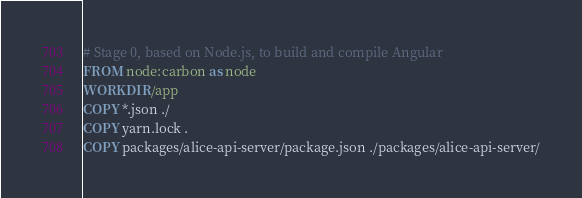Convert code to text. <code><loc_0><loc_0><loc_500><loc_500><_Dockerfile_># Stage 0, based on Node.js, to build and compile Angular
FROM node:carbon as node
WORKDIR /app
COPY *.json ./
COPY yarn.lock .
COPY packages/alice-api-server/package.json ./packages/alice-api-server/</code> 